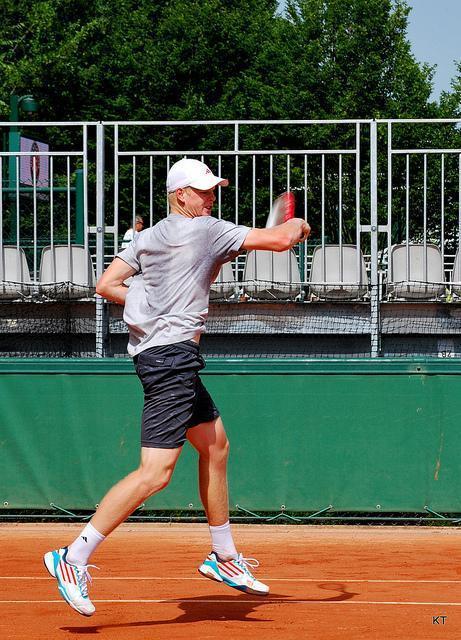How many chairs are there?
Give a very brief answer. 4. How many coffee cups are in the rack?
Give a very brief answer. 0. 